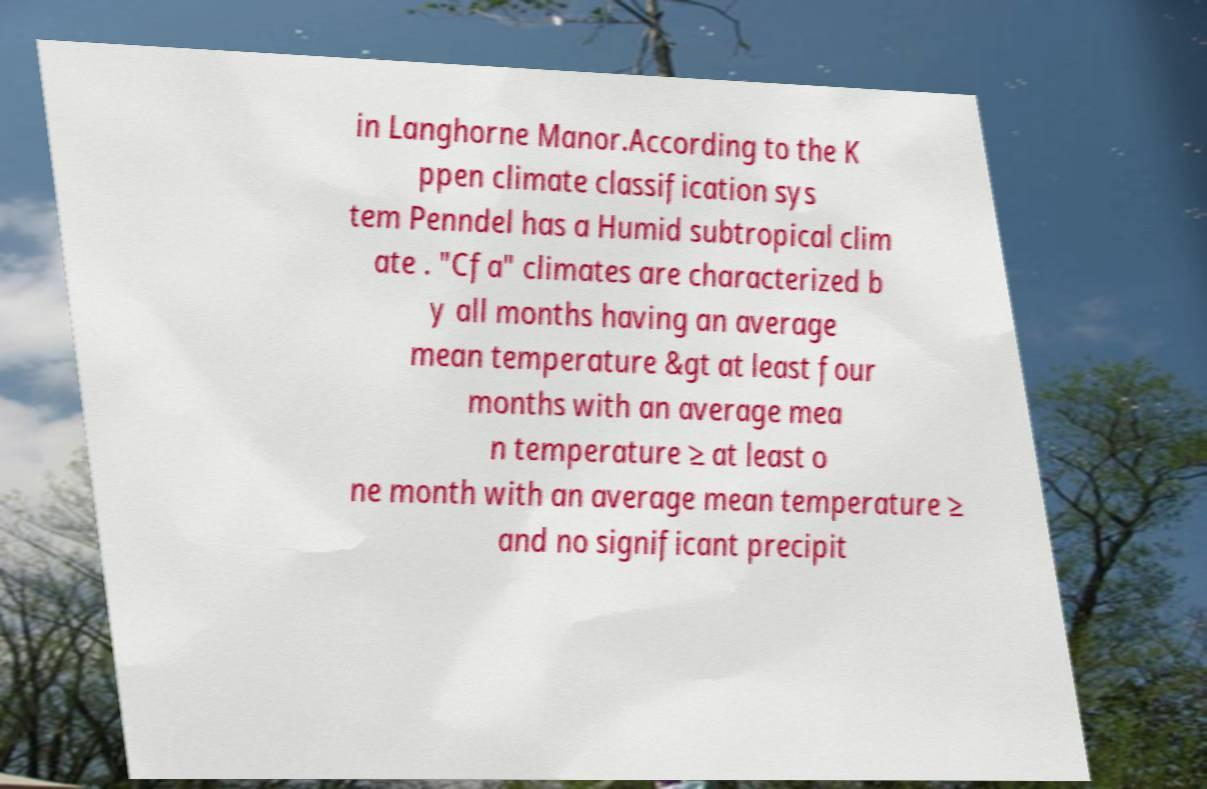There's text embedded in this image that I need extracted. Can you transcribe it verbatim? in Langhorne Manor.According to the K ppen climate classification sys tem Penndel has a Humid subtropical clim ate . "Cfa" climates are characterized b y all months having an average mean temperature &gt at least four months with an average mea n temperature ≥ at least o ne month with an average mean temperature ≥ and no significant precipit 